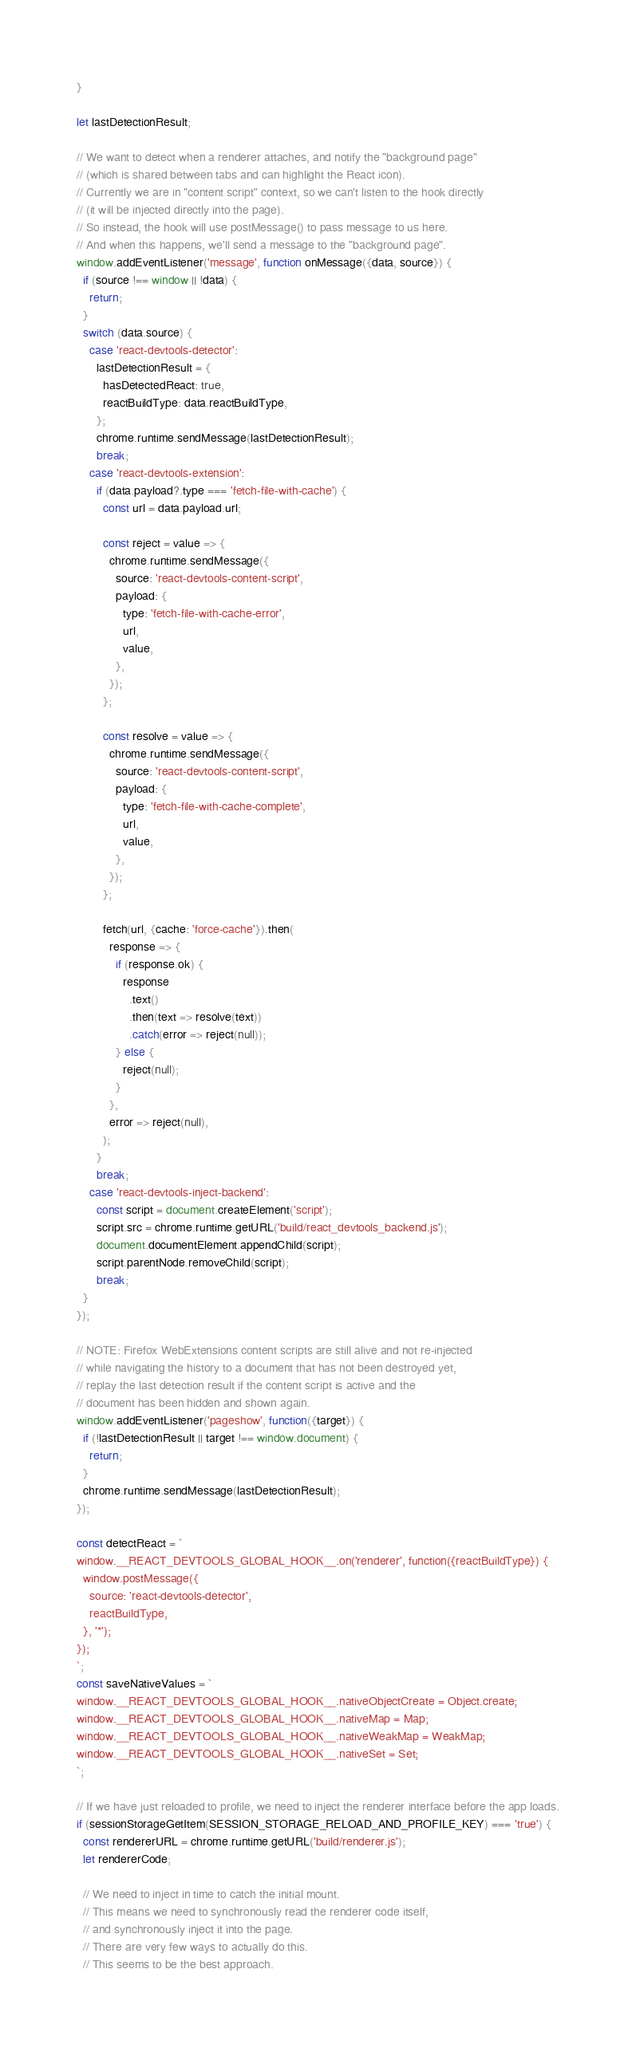<code> <loc_0><loc_0><loc_500><loc_500><_JavaScript_>}

let lastDetectionResult;

// We want to detect when a renderer attaches, and notify the "background page"
// (which is shared between tabs and can highlight the React icon).
// Currently we are in "content script" context, so we can't listen to the hook directly
// (it will be injected directly into the page).
// So instead, the hook will use postMessage() to pass message to us here.
// And when this happens, we'll send a message to the "background page".
window.addEventListener('message', function onMessage({data, source}) {
  if (source !== window || !data) {
    return;
  }
  switch (data.source) {
    case 'react-devtools-detector':
      lastDetectionResult = {
        hasDetectedReact: true,
        reactBuildType: data.reactBuildType,
      };
      chrome.runtime.sendMessage(lastDetectionResult);
      break;
    case 'react-devtools-extension':
      if (data.payload?.type === 'fetch-file-with-cache') {
        const url = data.payload.url;

        const reject = value => {
          chrome.runtime.sendMessage({
            source: 'react-devtools-content-script',
            payload: {
              type: 'fetch-file-with-cache-error',
              url,
              value,
            },
          });
        };

        const resolve = value => {
          chrome.runtime.sendMessage({
            source: 'react-devtools-content-script',
            payload: {
              type: 'fetch-file-with-cache-complete',
              url,
              value,
            },
          });
        };

        fetch(url, {cache: 'force-cache'}).then(
          response => {
            if (response.ok) {
              response
                .text()
                .then(text => resolve(text))
                .catch(error => reject(null));
            } else {
              reject(null);
            }
          },
          error => reject(null),
        );
      }
      break;
    case 'react-devtools-inject-backend':
      const script = document.createElement('script');
      script.src = chrome.runtime.getURL('build/react_devtools_backend.js');
      document.documentElement.appendChild(script);
      script.parentNode.removeChild(script);
      break;
  }
});

// NOTE: Firefox WebExtensions content scripts are still alive and not re-injected
// while navigating the history to a document that has not been destroyed yet,
// replay the last detection result if the content script is active and the
// document has been hidden and shown again.
window.addEventListener('pageshow', function({target}) {
  if (!lastDetectionResult || target !== window.document) {
    return;
  }
  chrome.runtime.sendMessage(lastDetectionResult);
});

const detectReact = `
window.__REACT_DEVTOOLS_GLOBAL_HOOK__.on('renderer', function({reactBuildType}) {
  window.postMessage({
    source: 'react-devtools-detector',
    reactBuildType,
  }, '*');
});
`;
const saveNativeValues = `
window.__REACT_DEVTOOLS_GLOBAL_HOOK__.nativeObjectCreate = Object.create;
window.__REACT_DEVTOOLS_GLOBAL_HOOK__.nativeMap = Map;
window.__REACT_DEVTOOLS_GLOBAL_HOOK__.nativeWeakMap = WeakMap;
window.__REACT_DEVTOOLS_GLOBAL_HOOK__.nativeSet = Set;
`;

// If we have just reloaded to profile, we need to inject the renderer interface before the app loads.
if (sessionStorageGetItem(SESSION_STORAGE_RELOAD_AND_PROFILE_KEY) === 'true') {
  const rendererURL = chrome.runtime.getURL('build/renderer.js');
  let rendererCode;

  // We need to inject in time to catch the initial mount.
  // This means we need to synchronously read the renderer code itself,
  // and synchronously inject it into the page.
  // There are very few ways to actually do this.
  // This seems to be the best approach.</code> 